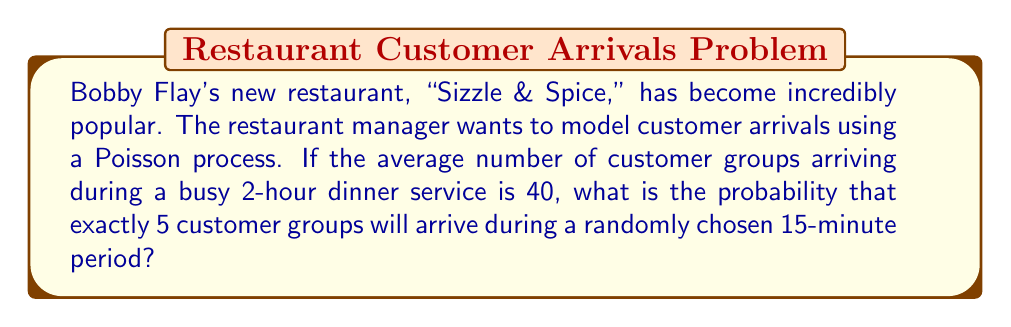What is the answer to this math problem? Let's approach this step-by-step:

1) First, we need to determine the rate parameter λ for the 15-minute period.

   Given:
   - 40 customer groups arrive in 2 hours
   - We want to find λ for a 15-minute period

   $$\lambda_{2 hours} = 40$$
   $$\lambda_{1 hour} = 20$$
   $$\lambda_{15 minutes} = 20 \times \frac{15}{60} = 5$$

2) Now we have a Poisson process with λ = 5 for a 15-minute period.

3) The probability of exactly k events occurring in a Poisson process is given by:

   $$P(X = k) = \frac{e^{-\lambda}\lambda^k}{k!}$$

4) We want P(X = 5), so let's substitute our values:

   $$P(X = 5) = \frac{e^{-5}5^5}{5!}$$

5) Let's calculate this step-by-step:
   
   $$\frac{e^{-5} \times 3125}{120}$$
   
   $$\frac{0.00673795 \times 3125}{120}$$
   
   $$\frac{21.0560937}{120}$$
   
   $$0.1754674475$$

6) Rounding to 4 decimal places:

   $$0.1755$$

Therefore, the probability of exactly 5 customer groups arriving during a randomly chosen 15-minute period is approximately 0.1755 or 17.55%.
Answer: 0.1755 